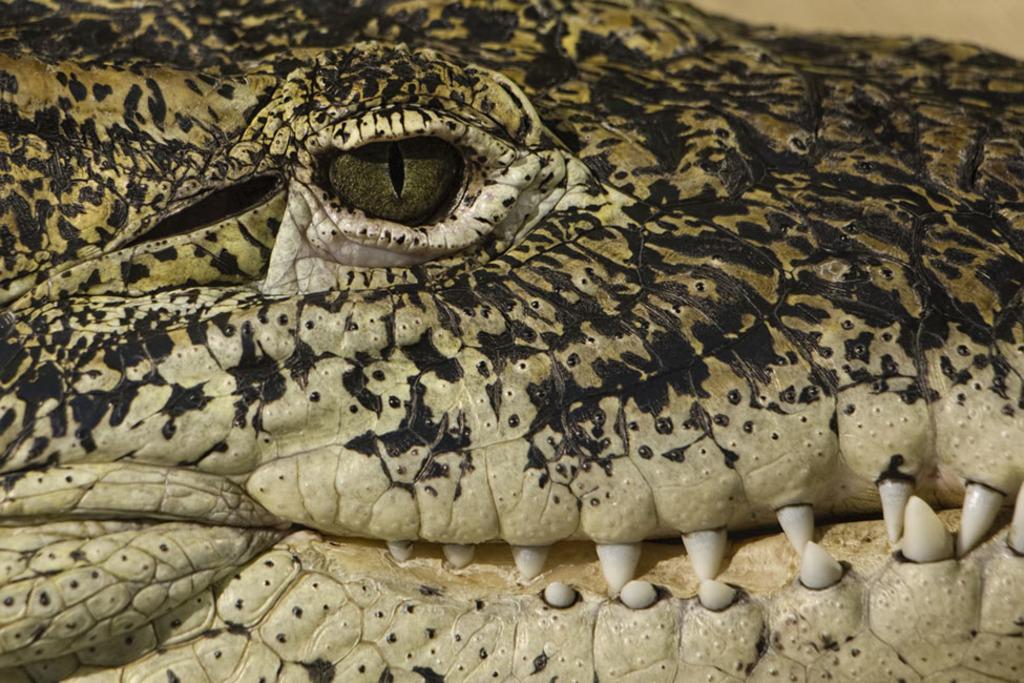Could you give a brief overview of what you see in this image? Here in this picture we can see a crocodile present, we can see its eye and teeth present over there. 